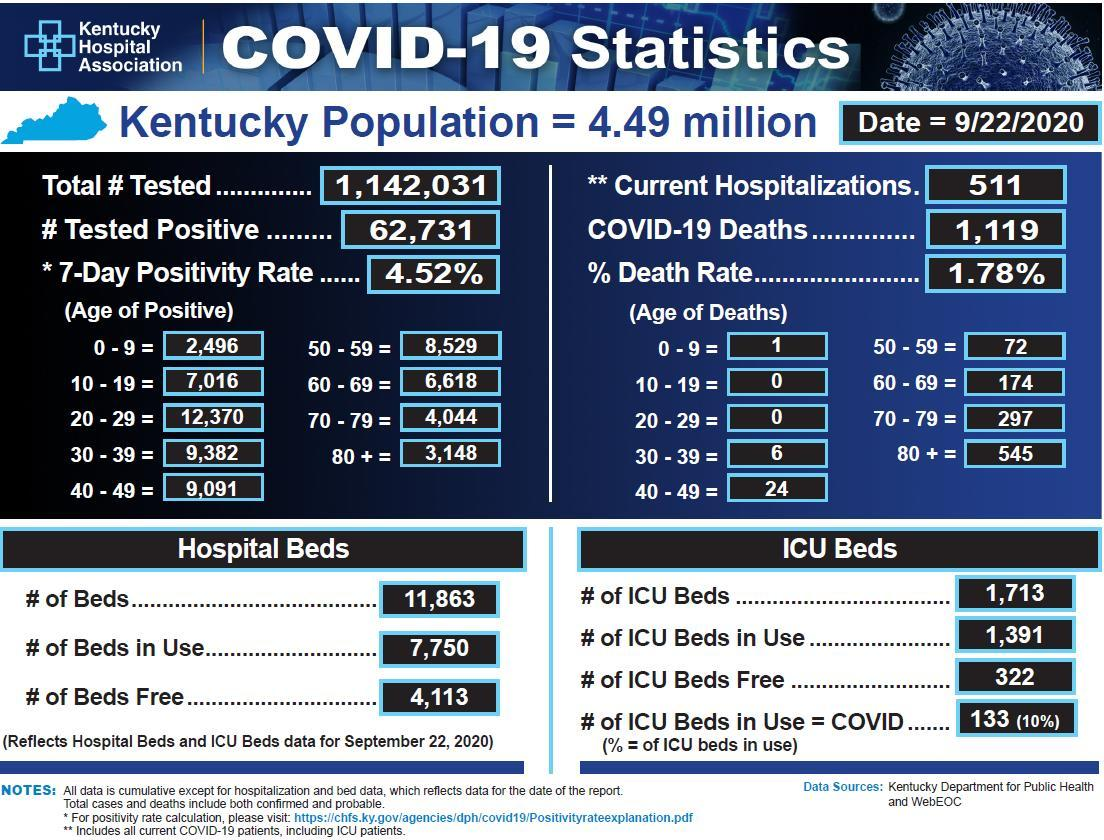What percentage of ICU beds are in use for covid patients  in Kentucky hospitals as of September 22, 2020?
Answer the question with a short phrase. (10%) What is the number of COVID-19 positive cases in Kentucky as of 9/22/2020? 62,731 How many COVID-19 deaths were reported in the age group of 50-59 years in Kentucky as of 9/22/2020? 72 What  is the death rate percentage due to COVID-19 in Kentucky as of 9/22/2020? 1.78% What is the number of ICU beds in use in Kentucky hospitals as of September 22, 2020? 1,391 How many people in Kentucky aged between 10-19 years had tested positive for COVID-19  as of 9/22/2020? 7,016 Which age group in Kentucky has reported the least number of Covid positive cases as of 9/22/2020? 0 - 9 How many COVID-19 deaths were reported in the age group of 40-49 years in Kentucky as of 9/22/2020? 24 What is the total number of people tested for COVID-19 in Kentucky as of 9/22/2020? 1,142,031 Which age group in Kentucky has reported the highest number of COVID-19 deaths as of 9/22/2020? 80+ 